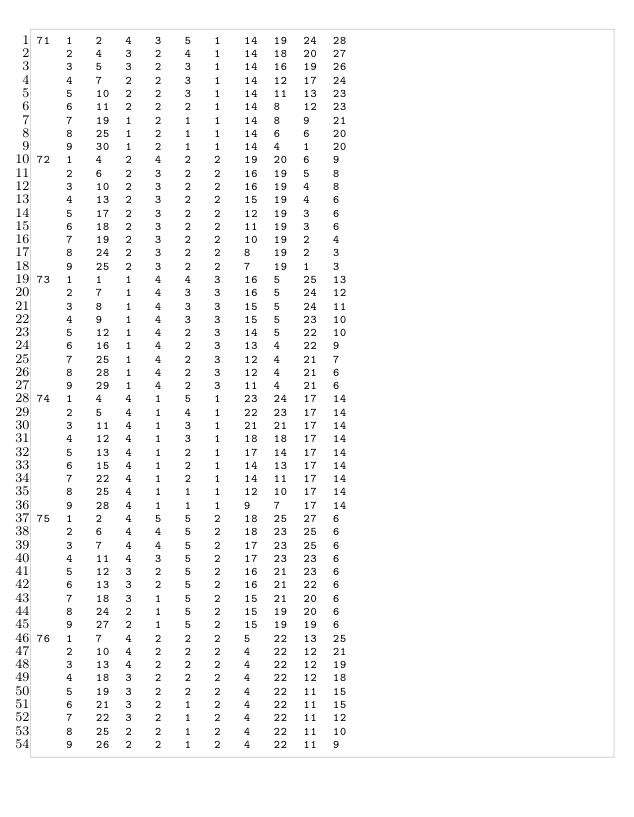Convert code to text. <code><loc_0><loc_0><loc_500><loc_500><_ObjectiveC_>71	1	2	4	3	5	1	14	19	24	28	
	2	4	3	2	4	1	14	18	20	27	
	3	5	3	2	3	1	14	16	19	26	
	4	7	2	2	3	1	14	12	17	24	
	5	10	2	2	3	1	14	11	13	23	
	6	11	2	2	2	1	14	8	12	23	
	7	19	1	2	1	1	14	8	9	21	
	8	25	1	2	1	1	14	6	6	20	
	9	30	1	2	1	1	14	4	1	20	
72	1	4	2	4	2	2	19	20	6	9	
	2	6	2	3	2	2	16	19	5	8	
	3	10	2	3	2	2	16	19	4	8	
	4	13	2	3	2	2	15	19	4	6	
	5	17	2	3	2	2	12	19	3	6	
	6	18	2	3	2	2	11	19	3	6	
	7	19	2	3	2	2	10	19	2	4	
	8	24	2	3	2	2	8	19	2	3	
	9	25	2	3	2	2	7	19	1	3	
73	1	1	1	4	4	3	16	5	25	13	
	2	7	1	4	3	3	16	5	24	12	
	3	8	1	4	3	3	15	5	24	11	
	4	9	1	4	3	3	15	5	23	10	
	5	12	1	4	2	3	14	5	22	10	
	6	16	1	4	2	3	13	4	22	9	
	7	25	1	4	2	3	12	4	21	7	
	8	28	1	4	2	3	12	4	21	6	
	9	29	1	4	2	3	11	4	21	6	
74	1	4	4	1	5	1	23	24	17	14	
	2	5	4	1	4	1	22	23	17	14	
	3	11	4	1	3	1	21	21	17	14	
	4	12	4	1	3	1	18	18	17	14	
	5	13	4	1	2	1	17	14	17	14	
	6	15	4	1	2	1	14	13	17	14	
	7	22	4	1	2	1	14	11	17	14	
	8	25	4	1	1	1	12	10	17	14	
	9	28	4	1	1	1	9	7	17	14	
75	1	2	4	5	5	2	18	25	27	6	
	2	6	4	4	5	2	18	23	25	6	
	3	7	4	4	5	2	17	23	25	6	
	4	11	4	3	5	2	17	23	23	6	
	5	12	3	2	5	2	16	21	23	6	
	6	13	3	2	5	2	16	21	22	6	
	7	18	3	1	5	2	15	21	20	6	
	8	24	2	1	5	2	15	19	20	6	
	9	27	2	1	5	2	15	19	19	6	
76	1	7	4	2	2	2	5	22	13	25	
	2	10	4	2	2	2	4	22	12	21	
	3	13	4	2	2	2	4	22	12	19	
	4	18	3	2	2	2	4	22	12	18	
	5	19	3	2	2	2	4	22	11	15	
	6	21	3	2	1	2	4	22	11	15	
	7	22	3	2	1	2	4	22	11	12	
	8	25	2	2	1	2	4	22	11	10	
	9	26	2	2	1	2	4	22	11	9	</code> 